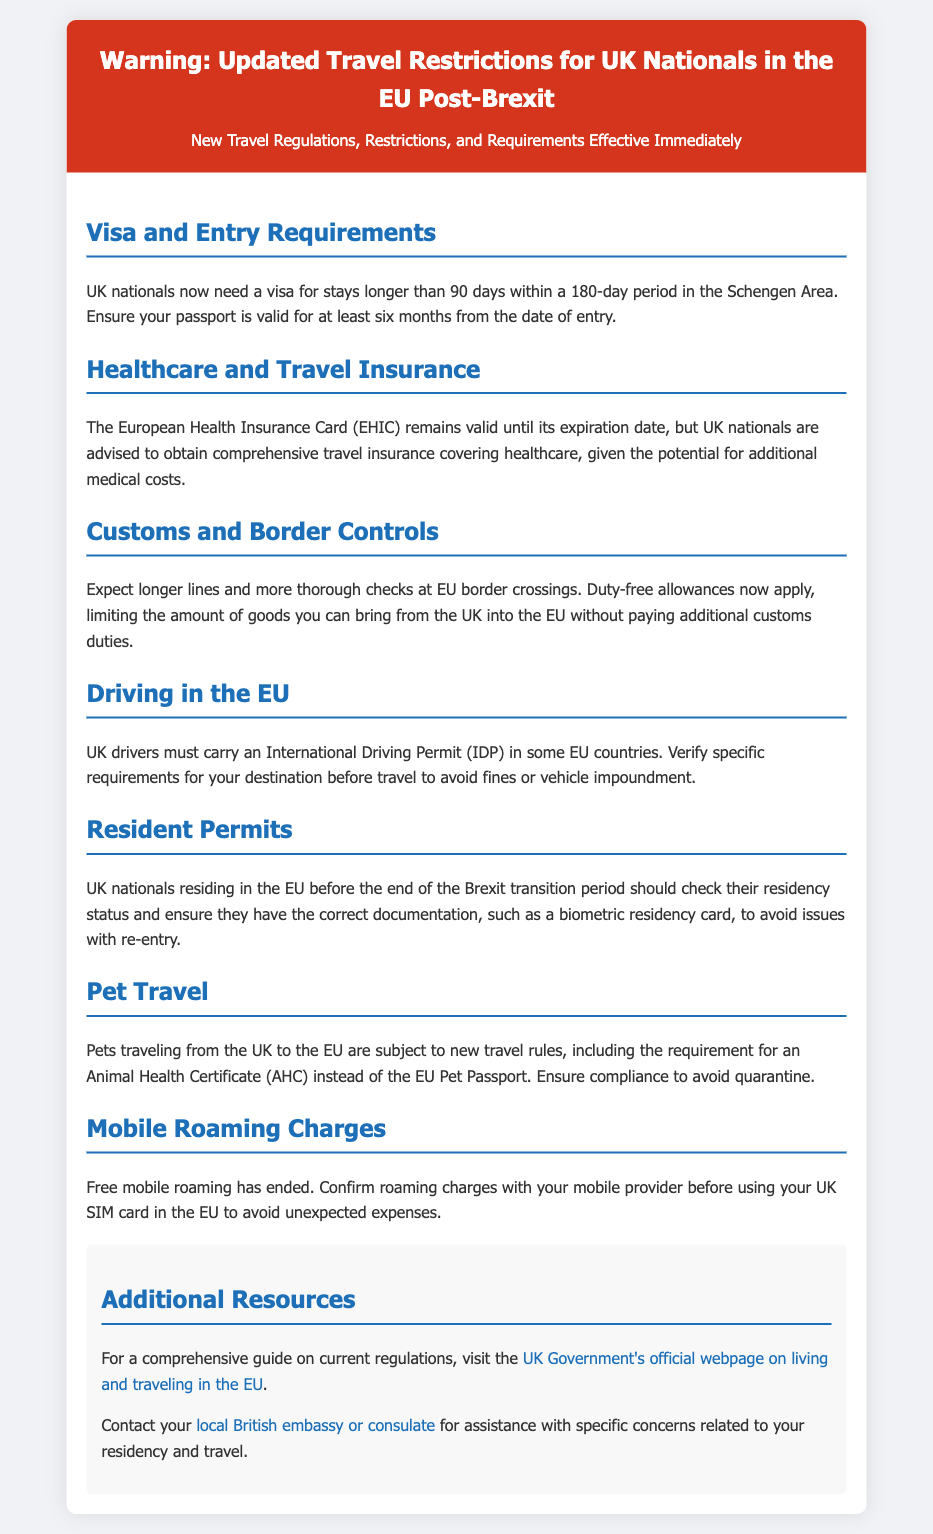What is the validity period for a UK passport when entering the EU? The document states that the passport must be valid for at least six months from the date of entry.
Answer: Six months What document do UK nationals now need for stays longer than 90 days? The warning label specifies that UK nationals need a visa for stays longer than 90 days within a 180-day period in the Schengen Area.
Answer: Visa What is required for pets traveling from the UK to the EU? The document mentions an Animal Health Certificate (AHC) is required instead of the EU Pet Passport.
Answer: Animal Health Certificate What has ended regarding mobile roaming charges? The document states that free mobile roaming has ended for UK nationals in the EU.
Answer: Ended What should UK nationals check regarding their residency status? The document advises that UK nationals residing in the EU should check their residency status and ensure correct documentation.
Answer: Correct documentation What must UK drivers carry in some EU countries? The document notes that UK drivers must carry an International Driving Permit (IDP) in some EU countries.
Answer: International Driving Permit How is healthcare coverage recommended for UK nationals traveling in the EU? The warning suggests that UK nationals should obtain comprehensive travel insurance covering healthcare.
Answer: Comprehensive travel insurance What should travelers expect at EU border crossings? The document states that travelers should expect longer lines and more thorough checks at EU border crossings.
Answer: Longer lines and more thorough checks 